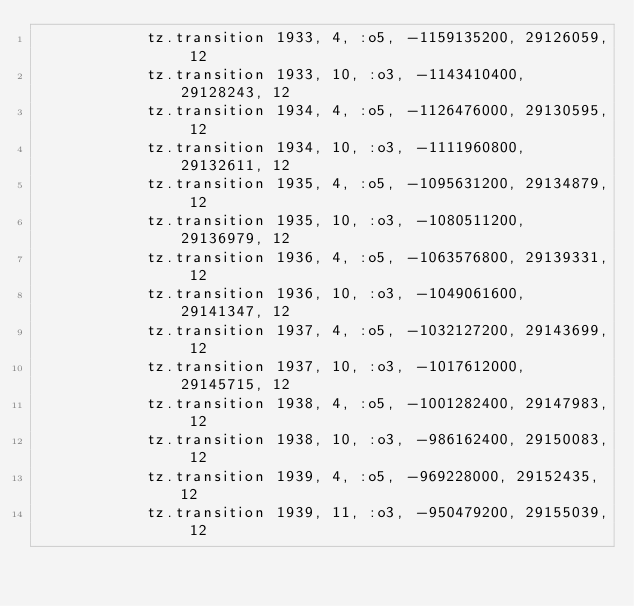Convert code to text. <code><loc_0><loc_0><loc_500><loc_500><_Ruby_>            tz.transition 1933, 4, :o5, -1159135200, 29126059, 12
            tz.transition 1933, 10, :o3, -1143410400, 29128243, 12
            tz.transition 1934, 4, :o5, -1126476000, 29130595, 12
            tz.transition 1934, 10, :o3, -1111960800, 29132611, 12
            tz.transition 1935, 4, :o5, -1095631200, 29134879, 12
            tz.transition 1935, 10, :o3, -1080511200, 29136979, 12
            tz.transition 1936, 4, :o5, -1063576800, 29139331, 12
            tz.transition 1936, 10, :o3, -1049061600, 29141347, 12
            tz.transition 1937, 4, :o5, -1032127200, 29143699, 12
            tz.transition 1937, 10, :o3, -1017612000, 29145715, 12
            tz.transition 1938, 4, :o5, -1001282400, 29147983, 12
            tz.transition 1938, 10, :o3, -986162400, 29150083, 12
            tz.transition 1939, 4, :o5, -969228000, 29152435, 12
            tz.transition 1939, 11, :o3, -950479200, 29155039, 12</code> 